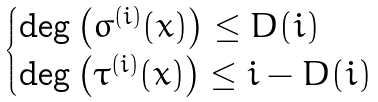<formula> <loc_0><loc_0><loc_500><loc_500>\begin{cases} \deg \left ( \sigma ^ { ( i ) } ( x ) \right ) \leq D ( i ) \\ \deg \left ( \tau ^ { ( i ) } ( x ) \right ) \leq i - D ( i ) \end{cases}</formula> 